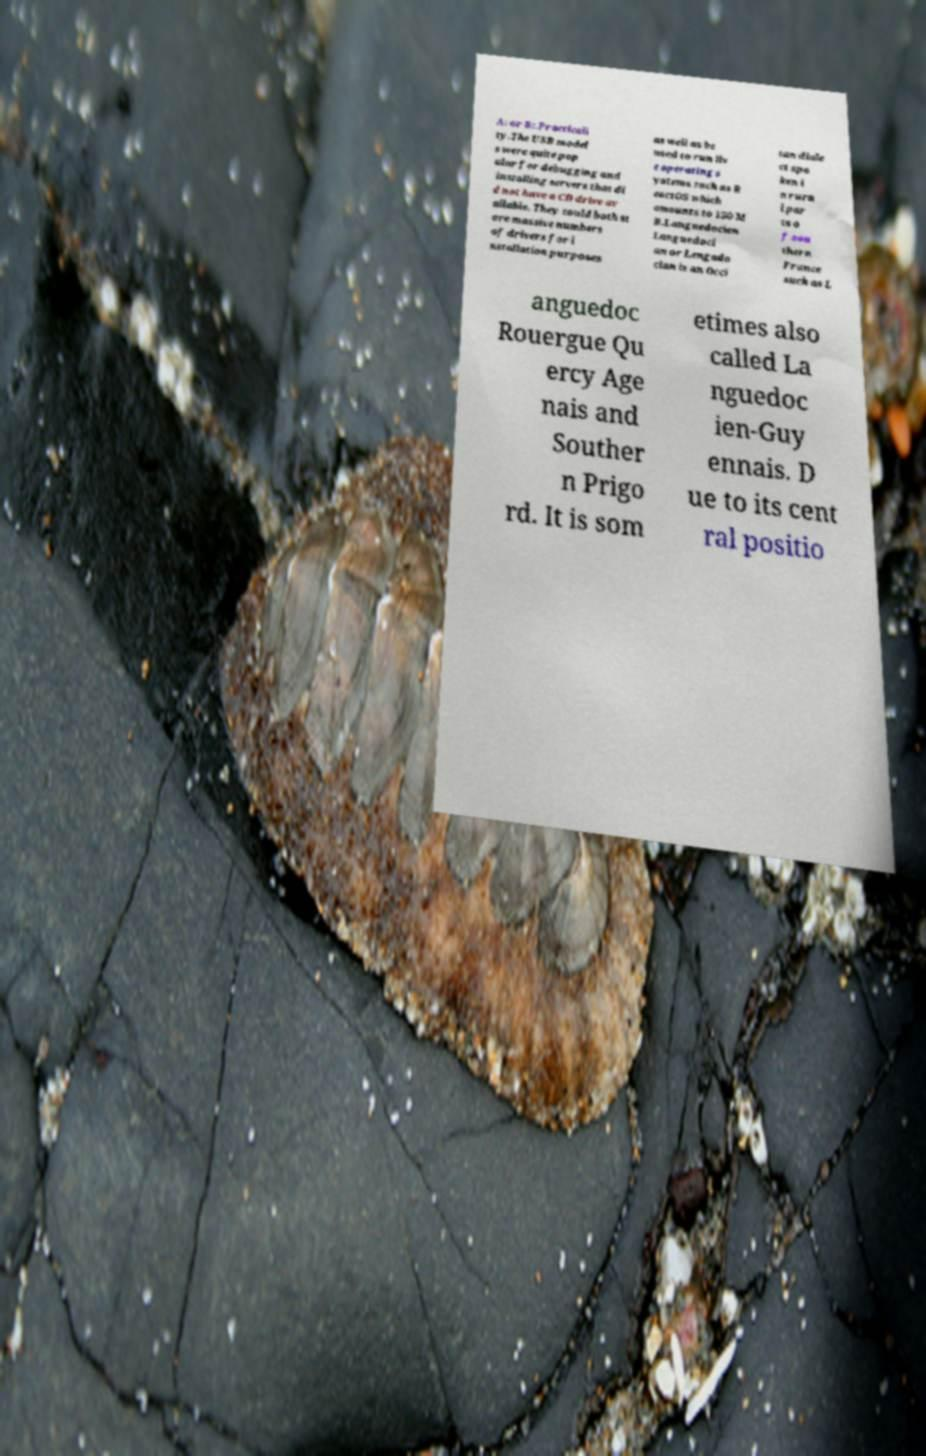Could you extract and type out the text from this image? A: or B:.Practicali ty.The USB model s were quite pop ular for debugging and installing servers that di d not have a CD drive av ailable. They could both st ore massive numbers of drivers for i nstallation purposes as well as be used to run liv e operating s ystems such as R eactOS which amounts to 150 M B.Languedocien Languedoci an or Lengado cian is an Occi tan diale ct spo ken i n rura l par ts o f sou thern France such as L anguedoc Rouergue Qu ercy Age nais and Souther n Prigo rd. It is som etimes also called La nguedoc ien-Guy ennais. D ue to its cent ral positio 